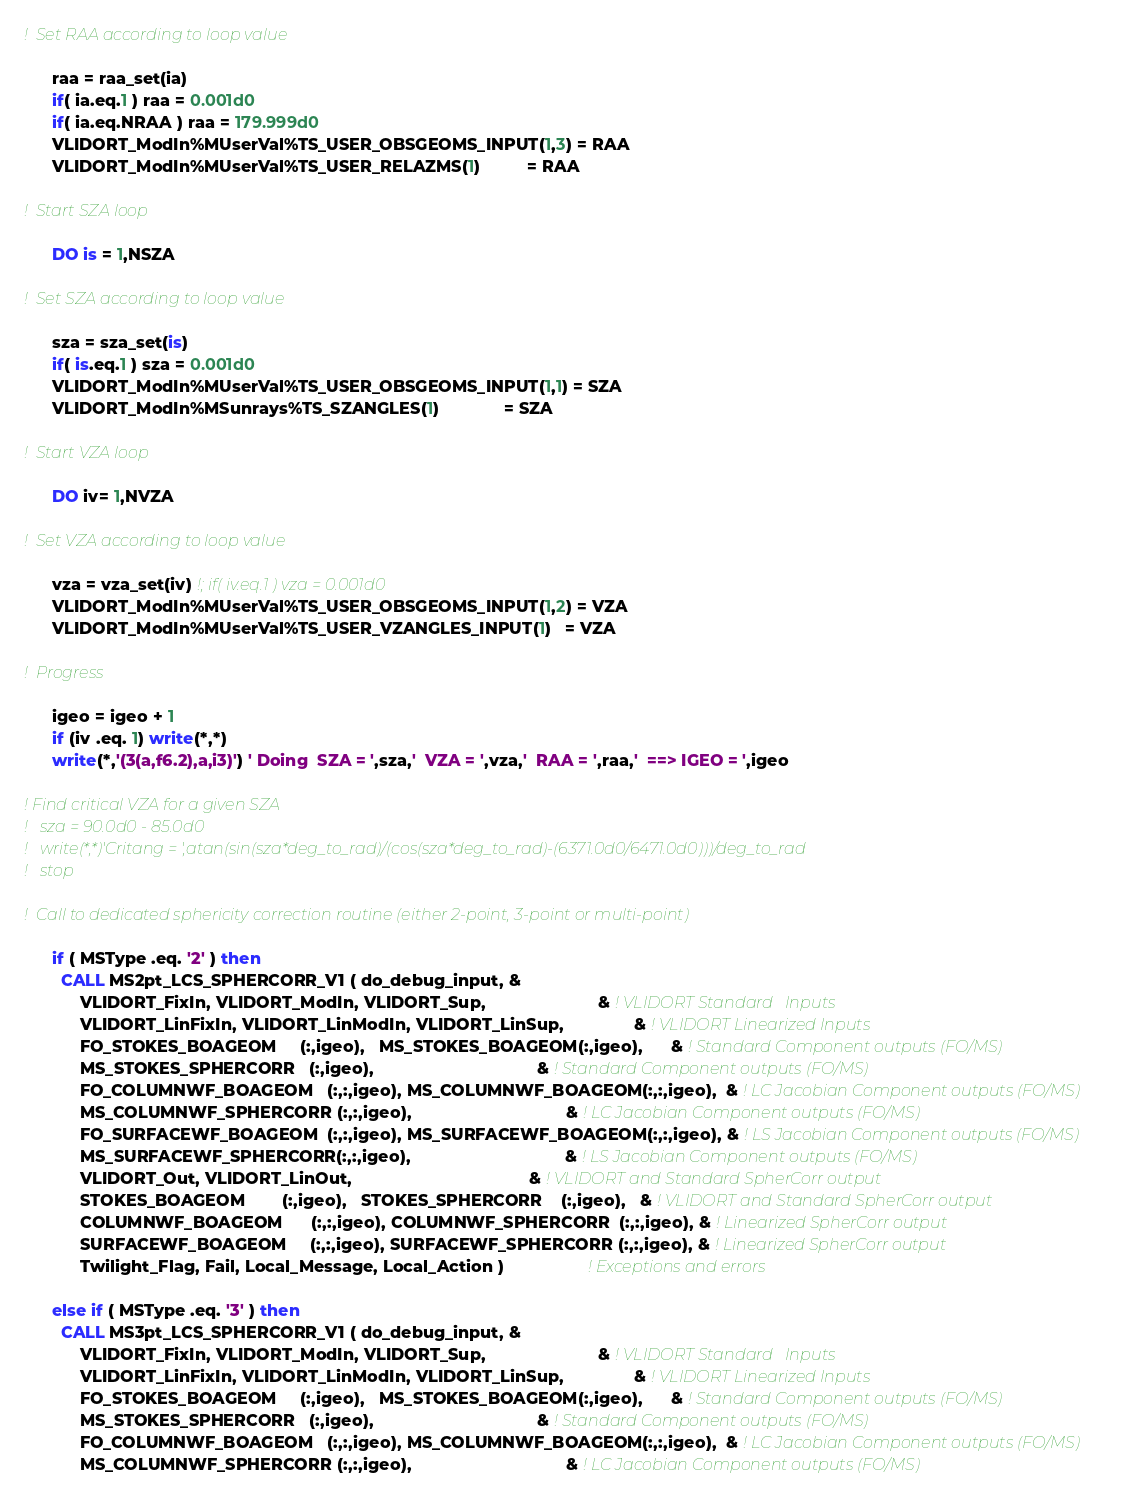<code> <loc_0><loc_0><loc_500><loc_500><_FORTRAN_>
!  Set RAA according to loop value

      raa = raa_set(ia)
      if( ia.eq.1 ) raa = 0.001d0 
      if( ia.eq.NRAA ) raa = 179.999d0
      VLIDORT_ModIn%MUserVal%TS_USER_OBSGEOMS_INPUT(1,3) = RAA
      VLIDORT_ModIn%MUserVal%TS_USER_RELAZMS(1)          = RAA

!  Start SZA loop

      DO is = 1,NSZA

!  Set SZA according to loop value

      sza = sza_set(is)
      if( is.eq.1 ) sza = 0.001d0
      VLIDORT_ModIn%MUserVal%TS_USER_OBSGEOMS_INPUT(1,1) = SZA
      VLIDORT_ModIn%MSunrays%TS_SZANGLES(1)              = SZA

!  Start VZA loop

      DO iv= 1,NVZA

!  Set VZA according to loop value

      vza = vza_set(iv) !; if( iv.eq.1 ) vza = 0.001d0 
      VLIDORT_ModIn%MUserVal%TS_USER_OBSGEOMS_INPUT(1,2) = VZA
      VLIDORT_ModIn%MUserVal%TS_USER_VZANGLES_INPUT(1)   = VZA

!  Progress

      igeo = igeo + 1
      if (iv .eq. 1) write(*,*)
      write(*,'(3(a,f6.2),a,i3)') ' Doing  SZA = ',sza,'  VZA = ',vza,'  RAA = ',raa,'  ==> IGEO = ',igeo

! Find critical VZA for a given SZA
!   sza = 90.0d0 - 85.0d0
!   write(*,*)'Critang = ',atan(sin(sza*deg_to_rad)/(cos(sza*deg_to_rad)-(6371.0d0/6471.0d0)))/deg_to_rad
!   stop

!  Call to dedicated sphericity correction routine (either 2-point, 3-point or multi-point)

      if ( MSType .eq. '2' ) then
        CALL MS2pt_LCS_SPHERCORR_V1 ( do_debug_input, &
            VLIDORT_FixIn, VLIDORT_ModIn, VLIDORT_Sup,                        & ! VLIDORT Standard   Inputs
            VLIDORT_LinFixIn, VLIDORT_LinModIn, VLIDORT_LinSup,               & ! VLIDORT Linearized Inputs
            FO_STOKES_BOAGEOM     (:,igeo),   MS_STOKES_BOAGEOM(:,igeo),      & ! Standard Component outputs (FO/MS)
            MS_STOKES_SPHERCORR   (:,igeo),                                   & ! Standard Component outputs (FO/MS)
            FO_COLUMNWF_BOAGEOM   (:,:,igeo), MS_COLUMNWF_BOAGEOM(:,:,igeo),  & ! LC Jacobian Component outputs (FO/MS)
            MS_COLUMNWF_SPHERCORR (:,:,igeo),                                 & ! LC Jacobian Component outputs (FO/MS)
            FO_SURFACEWF_BOAGEOM  (:,:,igeo), MS_SURFACEWF_BOAGEOM(:,:,igeo), & ! LS Jacobian Component outputs (FO/MS)
            MS_SURFACEWF_SPHERCORR(:,:,igeo),                                 & ! LS Jacobian Component outputs (FO/MS)
            VLIDORT_Out, VLIDORT_LinOut,                                      & ! VLIDORT and Standard SpherCorr output
            STOKES_BOAGEOM        (:,igeo),   STOKES_SPHERCORR    (:,igeo),   & ! VLIDORT and Standard SpherCorr output
            COLUMNWF_BOAGEOM      (:,:,igeo), COLUMNWF_SPHERCORR  (:,:,igeo), & ! Linearized SpherCorr output
            SURFACEWF_BOAGEOM     (:,:,igeo), SURFACEWF_SPHERCORR (:,:,igeo), & ! Linearized SpherCorr output
            Twilight_Flag, Fail, Local_Message, Local_Action )                  ! Exceptions and errors

      else if ( MSType .eq. '3' ) then
        CALL MS3pt_LCS_SPHERCORR_V1 ( do_debug_input, &
            VLIDORT_FixIn, VLIDORT_ModIn, VLIDORT_Sup,                        & ! VLIDORT Standard   Inputs
            VLIDORT_LinFixIn, VLIDORT_LinModIn, VLIDORT_LinSup,               & ! VLIDORT Linearized Inputs
            FO_STOKES_BOAGEOM     (:,igeo),   MS_STOKES_BOAGEOM(:,igeo),      & ! Standard Component outputs (FO/MS)
            MS_STOKES_SPHERCORR   (:,igeo),                                   & ! Standard Component outputs (FO/MS)
            FO_COLUMNWF_BOAGEOM   (:,:,igeo), MS_COLUMNWF_BOAGEOM(:,:,igeo),  & ! LC Jacobian Component outputs (FO/MS)
            MS_COLUMNWF_SPHERCORR (:,:,igeo),                                 & ! LC Jacobian Component outputs (FO/MS)</code> 